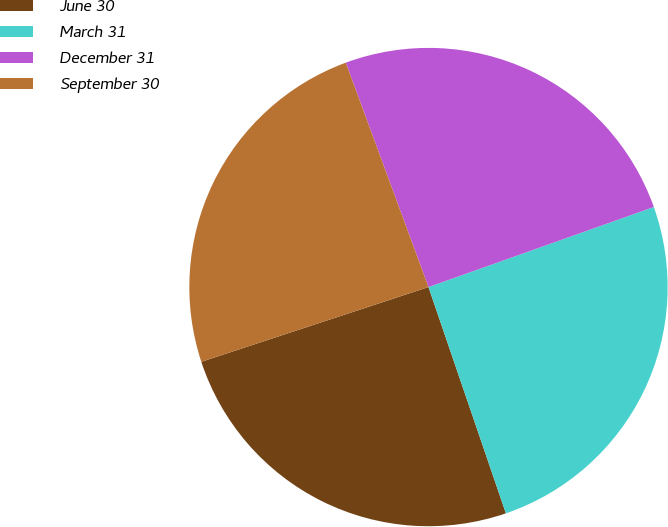<chart> <loc_0><loc_0><loc_500><loc_500><pie_chart><fcel>June 30<fcel>March 31<fcel>December 31<fcel>September 30<nl><fcel>25.19%<fcel>25.19%<fcel>25.19%<fcel>24.44%<nl></chart> 